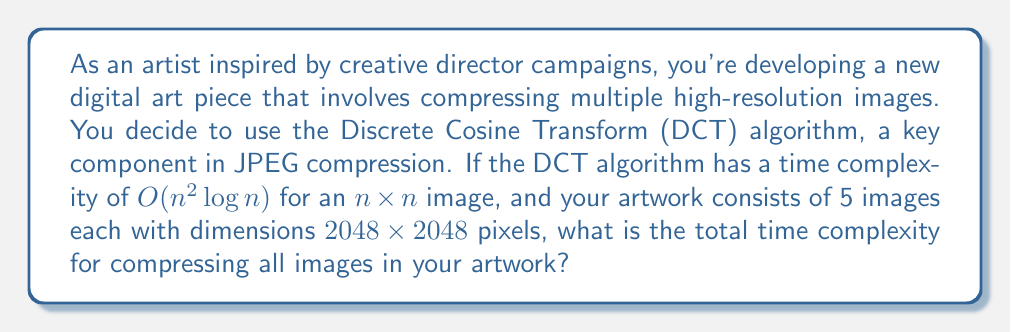Teach me how to tackle this problem. Let's approach this step-by-step:

1) First, we need to understand what the time complexity $O(n^2 \log n)$ means for a single $n \times n$ image:
   - $n^2$ represents the total number of pixels in the image
   - $\log n$ is due to the Fast Fourier Transform (FFT) used in the DCT algorithm

2) In this case, each image is $2048 \times 2048$ pixels, so $n = 2048$

3) For a single image, the time complexity is:
   $O((2048)^2 \log 2048)$

4) Simplifying:
   $O(4,194,304 \log 2048)$

5) Now, we need to consider that there are 5 images in total. Since we're dealing with big O notation, we multiply the complexity by 5:
   $5 \cdot O(4,194,304 \log 2048)$

6) In big O notation, constant factors are typically dropped, so this simplifies to:
   $O(4,194,304 \log 2048)$

7) This can be written more generally as:
   $O(n^2 \log n)$, where $n = 2048$

Therefore, the total time complexity remains $O(n^2 \log n)$, where $n$ is the dimension of each image (2048 in this case).
Answer: $O(n^2 \log n)$, where $n = 2048$ 